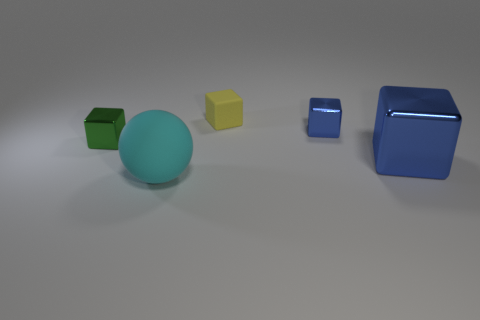There is a green thing; does it have the same size as the rubber object that is in front of the big blue cube?
Your response must be concise. No. What number of objects are either rubber objects behind the small blue shiny cube or objects that are behind the matte sphere?
Give a very brief answer. 4. There is a blue object that is the same size as the ball; what shape is it?
Your answer should be compact. Cube. What is the shape of the big thing that is behind the large object in front of the shiny thing in front of the green shiny object?
Keep it short and to the point. Cube. Are there the same number of tiny cubes to the left of the small blue metallic block and small blue cylinders?
Your response must be concise. No. Is the size of the yellow object the same as the green metallic thing?
Give a very brief answer. Yes. How many rubber objects are big cyan things or blue blocks?
Give a very brief answer. 1. What is the material of the yellow thing that is the same size as the green thing?
Make the answer very short. Rubber. How many other objects are there of the same material as the cyan ball?
Make the answer very short. 1. Are there fewer large blue things in front of the big blue cube than small things?
Your answer should be compact. Yes. 